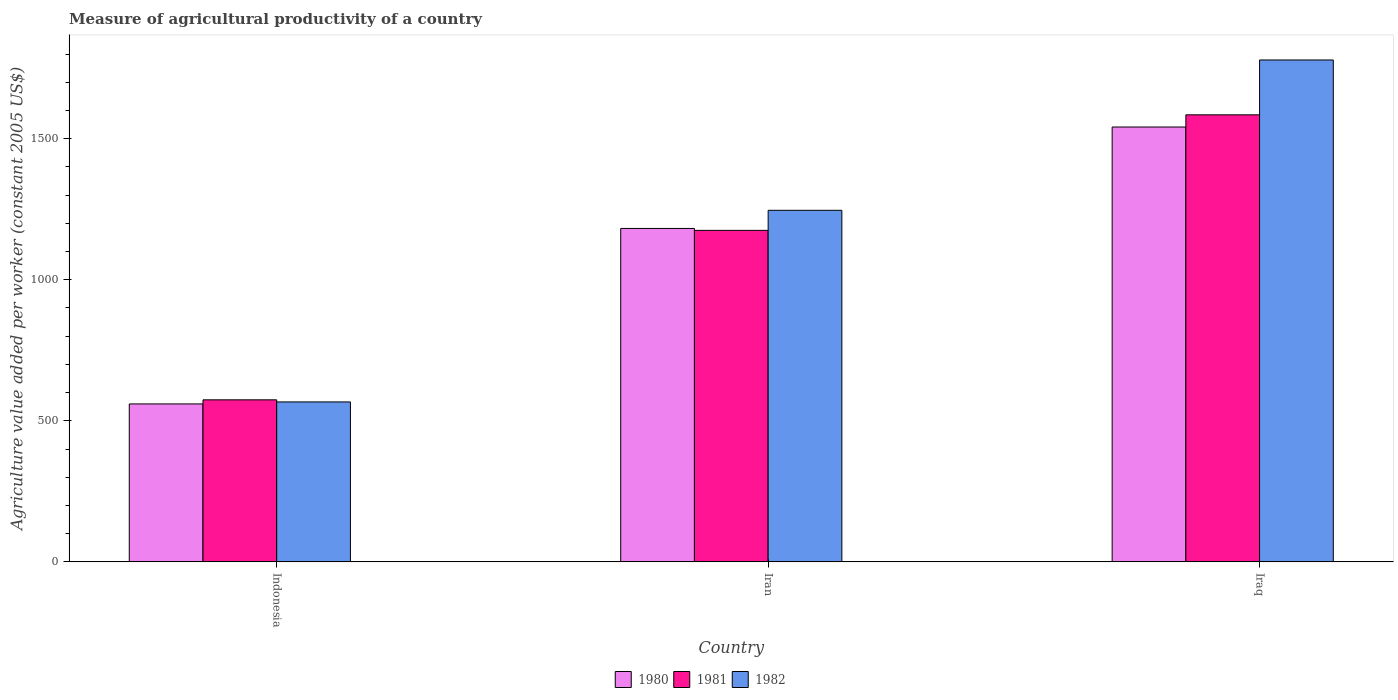How many different coloured bars are there?
Make the answer very short. 3. Are the number of bars per tick equal to the number of legend labels?
Your answer should be very brief. Yes. Are the number of bars on each tick of the X-axis equal?
Your response must be concise. Yes. In how many cases, is the number of bars for a given country not equal to the number of legend labels?
Your answer should be compact. 0. What is the measure of agricultural productivity in 1980 in Indonesia?
Make the answer very short. 559.91. Across all countries, what is the maximum measure of agricultural productivity in 1981?
Your answer should be compact. 1584.72. Across all countries, what is the minimum measure of agricultural productivity in 1981?
Your answer should be very brief. 574.41. In which country was the measure of agricultural productivity in 1982 maximum?
Provide a succinct answer. Iraq. In which country was the measure of agricultural productivity in 1980 minimum?
Offer a very short reply. Indonesia. What is the total measure of agricultural productivity in 1981 in the graph?
Make the answer very short. 3334.26. What is the difference between the measure of agricultural productivity in 1980 in Indonesia and that in Iraq?
Your answer should be very brief. -981.61. What is the difference between the measure of agricultural productivity in 1982 in Indonesia and the measure of agricultural productivity in 1980 in Iraq?
Offer a very short reply. -974.54. What is the average measure of agricultural productivity in 1982 per country?
Provide a short and direct response. 1197.47. What is the difference between the measure of agricultural productivity of/in 1982 and measure of agricultural productivity of/in 1981 in Indonesia?
Your response must be concise. -7.43. What is the ratio of the measure of agricultural productivity in 1981 in Indonesia to that in Iraq?
Provide a succinct answer. 0.36. Is the measure of agricultural productivity in 1982 in Indonesia less than that in Iraq?
Offer a terse response. Yes. What is the difference between the highest and the second highest measure of agricultural productivity in 1981?
Keep it short and to the point. 1010.31. What is the difference between the highest and the lowest measure of agricultural productivity in 1982?
Offer a terse response. 1212.19. In how many countries, is the measure of agricultural productivity in 1982 greater than the average measure of agricultural productivity in 1982 taken over all countries?
Provide a short and direct response. 2. Is the sum of the measure of agricultural productivity in 1982 in Indonesia and Iran greater than the maximum measure of agricultural productivity in 1980 across all countries?
Your answer should be very brief. Yes. What does the 2nd bar from the left in Iran represents?
Ensure brevity in your answer.  1981. How many bars are there?
Offer a terse response. 9. Are all the bars in the graph horizontal?
Ensure brevity in your answer.  No. How many countries are there in the graph?
Ensure brevity in your answer.  3. What is the difference between two consecutive major ticks on the Y-axis?
Offer a very short reply. 500. Does the graph contain grids?
Your answer should be very brief. No. Where does the legend appear in the graph?
Your response must be concise. Bottom center. How many legend labels are there?
Offer a very short reply. 3. What is the title of the graph?
Give a very brief answer. Measure of agricultural productivity of a country. Does "1967" appear as one of the legend labels in the graph?
Offer a terse response. No. What is the label or title of the Y-axis?
Offer a very short reply. Agriculture value added per worker (constant 2005 US$). What is the Agriculture value added per worker (constant 2005 US$) in 1980 in Indonesia?
Make the answer very short. 559.91. What is the Agriculture value added per worker (constant 2005 US$) of 1981 in Indonesia?
Your answer should be very brief. 574.41. What is the Agriculture value added per worker (constant 2005 US$) in 1982 in Indonesia?
Make the answer very short. 566.98. What is the Agriculture value added per worker (constant 2005 US$) of 1980 in Iran?
Your response must be concise. 1181.95. What is the Agriculture value added per worker (constant 2005 US$) in 1981 in Iran?
Give a very brief answer. 1175.14. What is the Agriculture value added per worker (constant 2005 US$) in 1982 in Iran?
Your answer should be very brief. 1246.26. What is the Agriculture value added per worker (constant 2005 US$) of 1980 in Iraq?
Provide a short and direct response. 1541.52. What is the Agriculture value added per worker (constant 2005 US$) in 1981 in Iraq?
Your response must be concise. 1584.72. What is the Agriculture value added per worker (constant 2005 US$) in 1982 in Iraq?
Your answer should be very brief. 1779.17. Across all countries, what is the maximum Agriculture value added per worker (constant 2005 US$) of 1980?
Offer a terse response. 1541.52. Across all countries, what is the maximum Agriculture value added per worker (constant 2005 US$) of 1981?
Offer a very short reply. 1584.72. Across all countries, what is the maximum Agriculture value added per worker (constant 2005 US$) of 1982?
Ensure brevity in your answer.  1779.17. Across all countries, what is the minimum Agriculture value added per worker (constant 2005 US$) of 1980?
Ensure brevity in your answer.  559.91. Across all countries, what is the minimum Agriculture value added per worker (constant 2005 US$) in 1981?
Provide a succinct answer. 574.41. Across all countries, what is the minimum Agriculture value added per worker (constant 2005 US$) in 1982?
Give a very brief answer. 566.98. What is the total Agriculture value added per worker (constant 2005 US$) in 1980 in the graph?
Your response must be concise. 3283.38. What is the total Agriculture value added per worker (constant 2005 US$) in 1981 in the graph?
Provide a succinct answer. 3334.26. What is the total Agriculture value added per worker (constant 2005 US$) of 1982 in the graph?
Offer a terse response. 3592.41. What is the difference between the Agriculture value added per worker (constant 2005 US$) in 1980 in Indonesia and that in Iran?
Offer a very short reply. -622.04. What is the difference between the Agriculture value added per worker (constant 2005 US$) of 1981 in Indonesia and that in Iran?
Give a very brief answer. -600.73. What is the difference between the Agriculture value added per worker (constant 2005 US$) in 1982 in Indonesia and that in Iran?
Your answer should be very brief. -679.28. What is the difference between the Agriculture value added per worker (constant 2005 US$) of 1980 in Indonesia and that in Iraq?
Your answer should be very brief. -981.61. What is the difference between the Agriculture value added per worker (constant 2005 US$) in 1981 in Indonesia and that in Iraq?
Keep it short and to the point. -1010.31. What is the difference between the Agriculture value added per worker (constant 2005 US$) in 1982 in Indonesia and that in Iraq?
Keep it short and to the point. -1212.19. What is the difference between the Agriculture value added per worker (constant 2005 US$) of 1980 in Iran and that in Iraq?
Offer a very short reply. -359.58. What is the difference between the Agriculture value added per worker (constant 2005 US$) of 1981 in Iran and that in Iraq?
Provide a short and direct response. -409.57. What is the difference between the Agriculture value added per worker (constant 2005 US$) in 1982 in Iran and that in Iraq?
Provide a succinct answer. -532.92. What is the difference between the Agriculture value added per worker (constant 2005 US$) in 1980 in Indonesia and the Agriculture value added per worker (constant 2005 US$) in 1981 in Iran?
Give a very brief answer. -615.23. What is the difference between the Agriculture value added per worker (constant 2005 US$) of 1980 in Indonesia and the Agriculture value added per worker (constant 2005 US$) of 1982 in Iran?
Ensure brevity in your answer.  -686.35. What is the difference between the Agriculture value added per worker (constant 2005 US$) in 1981 in Indonesia and the Agriculture value added per worker (constant 2005 US$) in 1982 in Iran?
Your answer should be very brief. -671.85. What is the difference between the Agriculture value added per worker (constant 2005 US$) in 1980 in Indonesia and the Agriculture value added per worker (constant 2005 US$) in 1981 in Iraq?
Ensure brevity in your answer.  -1024.81. What is the difference between the Agriculture value added per worker (constant 2005 US$) of 1980 in Indonesia and the Agriculture value added per worker (constant 2005 US$) of 1982 in Iraq?
Offer a very short reply. -1219.26. What is the difference between the Agriculture value added per worker (constant 2005 US$) of 1981 in Indonesia and the Agriculture value added per worker (constant 2005 US$) of 1982 in Iraq?
Make the answer very short. -1204.77. What is the difference between the Agriculture value added per worker (constant 2005 US$) of 1980 in Iran and the Agriculture value added per worker (constant 2005 US$) of 1981 in Iraq?
Give a very brief answer. -402.77. What is the difference between the Agriculture value added per worker (constant 2005 US$) in 1980 in Iran and the Agriculture value added per worker (constant 2005 US$) in 1982 in Iraq?
Keep it short and to the point. -597.23. What is the difference between the Agriculture value added per worker (constant 2005 US$) of 1981 in Iran and the Agriculture value added per worker (constant 2005 US$) of 1982 in Iraq?
Make the answer very short. -604.03. What is the average Agriculture value added per worker (constant 2005 US$) of 1980 per country?
Give a very brief answer. 1094.46. What is the average Agriculture value added per worker (constant 2005 US$) in 1981 per country?
Give a very brief answer. 1111.42. What is the average Agriculture value added per worker (constant 2005 US$) of 1982 per country?
Provide a succinct answer. 1197.47. What is the difference between the Agriculture value added per worker (constant 2005 US$) in 1980 and Agriculture value added per worker (constant 2005 US$) in 1981 in Indonesia?
Offer a terse response. -14.5. What is the difference between the Agriculture value added per worker (constant 2005 US$) in 1980 and Agriculture value added per worker (constant 2005 US$) in 1982 in Indonesia?
Provide a succinct answer. -7.07. What is the difference between the Agriculture value added per worker (constant 2005 US$) of 1981 and Agriculture value added per worker (constant 2005 US$) of 1982 in Indonesia?
Keep it short and to the point. 7.43. What is the difference between the Agriculture value added per worker (constant 2005 US$) in 1980 and Agriculture value added per worker (constant 2005 US$) in 1981 in Iran?
Provide a short and direct response. 6.8. What is the difference between the Agriculture value added per worker (constant 2005 US$) of 1980 and Agriculture value added per worker (constant 2005 US$) of 1982 in Iran?
Your answer should be very brief. -64.31. What is the difference between the Agriculture value added per worker (constant 2005 US$) of 1981 and Agriculture value added per worker (constant 2005 US$) of 1982 in Iran?
Your answer should be compact. -71.12. What is the difference between the Agriculture value added per worker (constant 2005 US$) of 1980 and Agriculture value added per worker (constant 2005 US$) of 1981 in Iraq?
Your answer should be very brief. -43.19. What is the difference between the Agriculture value added per worker (constant 2005 US$) in 1980 and Agriculture value added per worker (constant 2005 US$) in 1982 in Iraq?
Your response must be concise. -237.65. What is the difference between the Agriculture value added per worker (constant 2005 US$) of 1981 and Agriculture value added per worker (constant 2005 US$) of 1982 in Iraq?
Your answer should be compact. -194.46. What is the ratio of the Agriculture value added per worker (constant 2005 US$) in 1980 in Indonesia to that in Iran?
Your response must be concise. 0.47. What is the ratio of the Agriculture value added per worker (constant 2005 US$) of 1981 in Indonesia to that in Iran?
Provide a succinct answer. 0.49. What is the ratio of the Agriculture value added per worker (constant 2005 US$) in 1982 in Indonesia to that in Iran?
Offer a very short reply. 0.45. What is the ratio of the Agriculture value added per worker (constant 2005 US$) of 1980 in Indonesia to that in Iraq?
Offer a terse response. 0.36. What is the ratio of the Agriculture value added per worker (constant 2005 US$) in 1981 in Indonesia to that in Iraq?
Give a very brief answer. 0.36. What is the ratio of the Agriculture value added per worker (constant 2005 US$) of 1982 in Indonesia to that in Iraq?
Make the answer very short. 0.32. What is the ratio of the Agriculture value added per worker (constant 2005 US$) of 1980 in Iran to that in Iraq?
Offer a terse response. 0.77. What is the ratio of the Agriculture value added per worker (constant 2005 US$) of 1981 in Iran to that in Iraq?
Give a very brief answer. 0.74. What is the ratio of the Agriculture value added per worker (constant 2005 US$) in 1982 in Iran to that in Iraq?
Offer a very short reply. 0.7. What is the difference between the highest and the second highest Agriculture value added per worker (constant 2005 US$) of 1980?
Your answer should be compact. 359.58. What is the difference between the highest and the second highest Agriculture value added per worker (constant 2005 US$) of 1981?
Ensure brevity in your answer.  409.57. What is the difference between the highest and the second highest Agriculture value added per worker (constant 2005 US$) of 1982?
Make the answer very short. 532.92. What is the difference between the highest and the lowest Agriculture value added per worker (constant 2005 US$) of 1980?
Keep it short and to the point. 981.61. What is the difference between the highest and the lowest Agriculture value added per worker (constant 2005 US$) of 1981?
Provide a succinct answer. 1010.31. What is the difference between the highest and the lowest Agriculture value added per worker (constant 2005 US$) of 1982?
Give a very brief answer. 1212.19. 